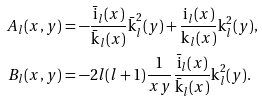Convert formula to latex. <formula><loc_0><loc_0><loc_500><loc_500>A _ { l } ( x , y ) & = - \frac { \bar { \text {i} } _ { l } ( x ) } { \bar { \text {k} } _ { l } ( x ) } \bar { \text {k} } _ { l } ^ { 2 } ( y ) + \frac { \text {i} _ { l } ( x ) } { \text {k} _ { l } ( x ) } \text {k} _ { l } ^ { 2 } ( y ) , \\ B _ { l } ( x , y ) & = - 2 l ( l + 1 ) \frac { 1 } { x y } \frac { \bar { \text {i} } _ { l } ( x ) } { \bar { \text {k} } _ { l } ( x ) } \text {k} _ { l } ^ { 2 } ( y ) .</formula> 